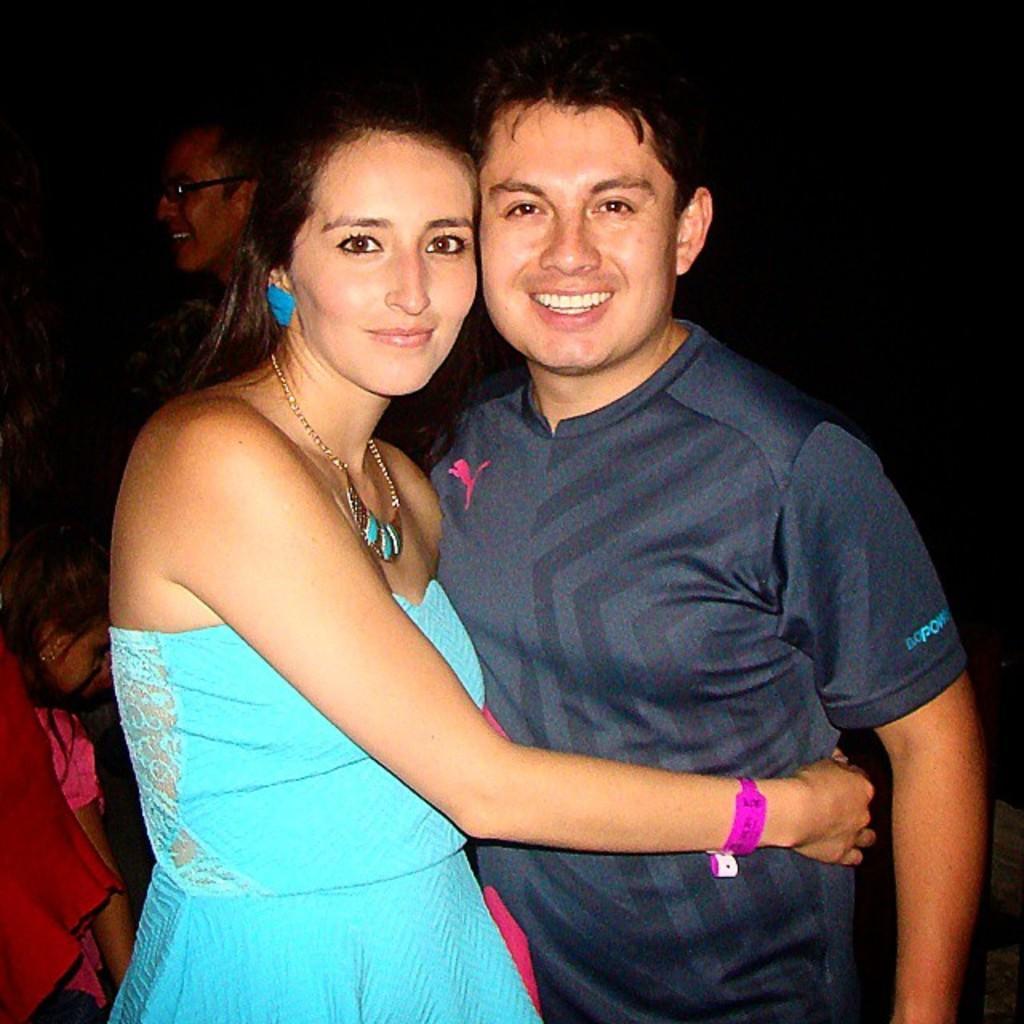Could you give a brief overview of what you see in this image? In this image there are two persons standing as we can see in the middle of this image and there are some persons on the left side of this image as well. 